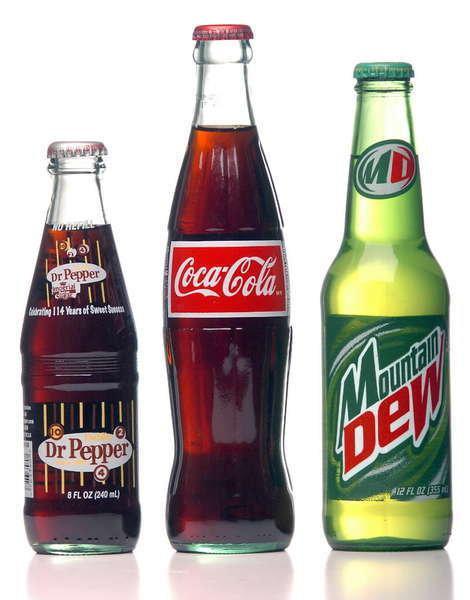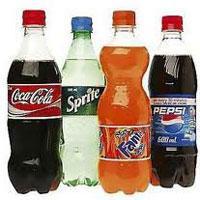The first image is the image on the left, the second image is the image on the right. Given the left and right images, does the statement "No image contains more than four bottles, and the left image shows a row of three bottles that aren't overlapping." hold true? Answer yes or no. Yes. The first image is the image on the left, the second image is the image on the right. Examine the images to the left and right. Is the description "There are fewer than seven bottles in total." accurate? Answer yes or no. No. 